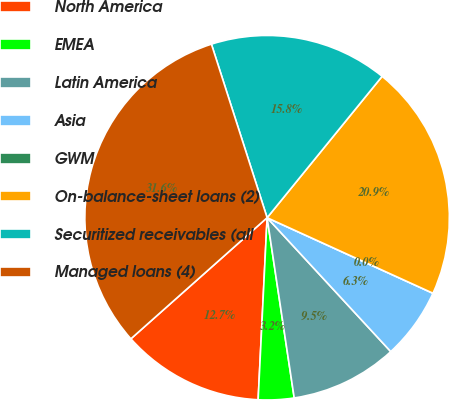Convert chart to OTSL. <chart><loc_0><loc_0><loc_500><loc_500><pie_chart><fcel>North America<fcel>EMEA<fcel>Latin America<fcel>Asia<fcel>GWM<fcel>On-balance-sheet loans (2)<fcel>Securitized receivables (all<fcel>Managed loans (4)<nl><fcel>12.65%<fcel>3.16%<fcel>9.49%<fcel>6.33%<fcel>0.0%<fcel>20.93%<fcel>15.81%<fcel>31.62%<nl></chart> 